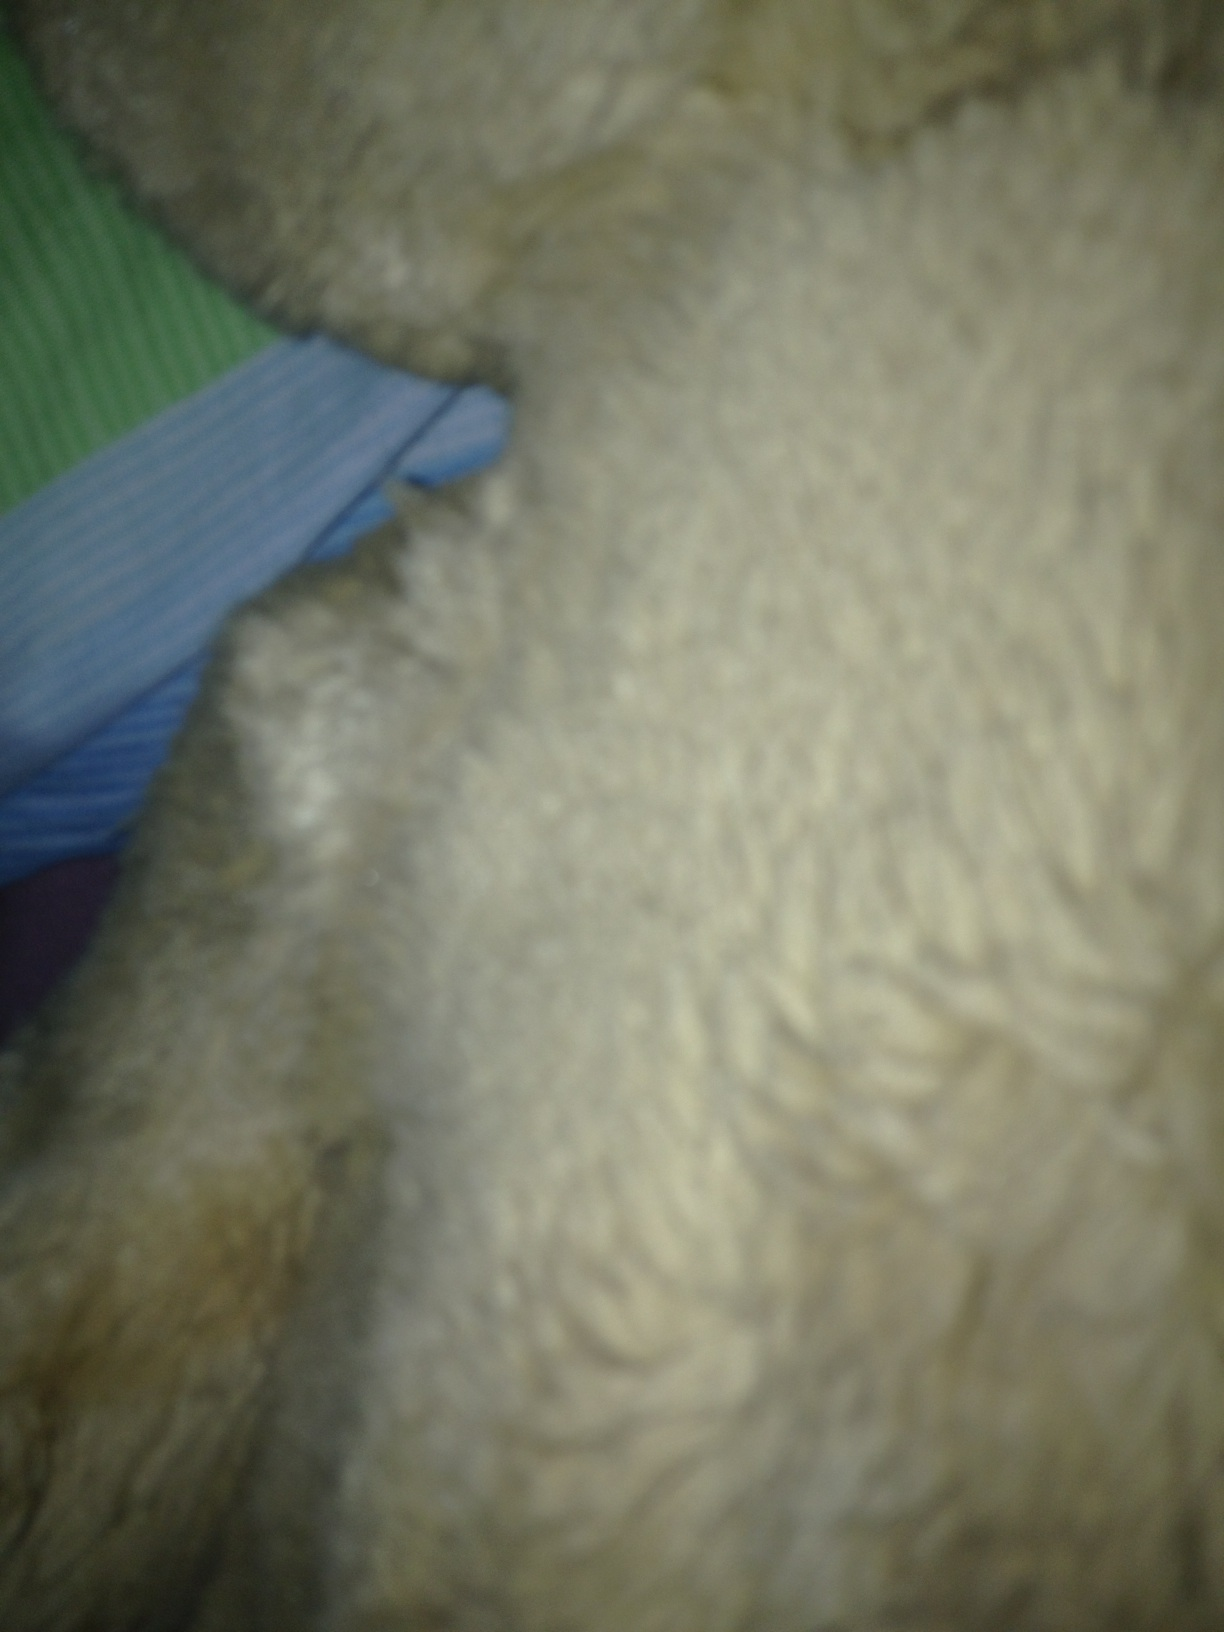Imagine this texture is part of an enchanted forest. What could it be? In an enchanted forest, this fuzzy texture might be the coat of a mystical creature, like a friendly guardian beast that roams the woods, protecting the magical realm. The creature would have a coat that feels as soft and warm as this to provide comfort to lost travelers. The hints of green and blue in the background could be the shimmering leaves and ethereal glow of the enchanted forest. What kind of scenarios can you create around this enchanted creature? A young adventurer stumbles into an enchanted forest during their quest for a legendary artifact. As they wander through the misty, glowing underbrush, they are startled to find themselves face-to-face with a massive, furry creature with eyes that sparkle like stars. Instead of attacking, the creature gently nuzzles them, sensing their pure heart. The creature then guides them through the forest, revealing hidden pathways and protecting them from darker forces lurking in the shadows. Along the way, the adventurer learns the ancient lore of the forest, unlocking clues to the artifact's location. In the end, the creature leads them to a secret glade where the artifact rests upon an altar of luminescent flowers, completing their quest. 